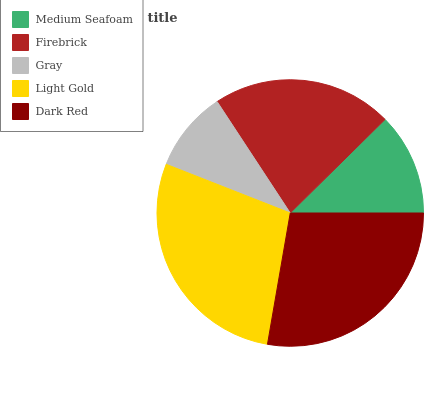Is Gray the minimum?
Answer yes or no. Yes. Is Light Gold the maximum?
Answer yes or no. Yes. Is Firebrick the minimum?
Answer yes or no. No. Is Firebrick the maximum?
Answer yes or no. No. Is Firebrick greater than Medium Seafoam?
Answer yes or no. Yes. Is Medium Seafoam less than Firebrick?
Answer yes or no. Yes. Is Medium Seafoam greater than Firebrick?
Answer yes or no. No. Is Firebrick less than Medium Seafoam?
Answer yes or no. No. Is Firebrick the high median?
Answer yes or no. Yes. Is Firebrick the low median?
Answer yes or no. Yes. Is Dark Red the high median?
Answer yes or no. No. Is Gray the low median?
Answer yes or no. No. 